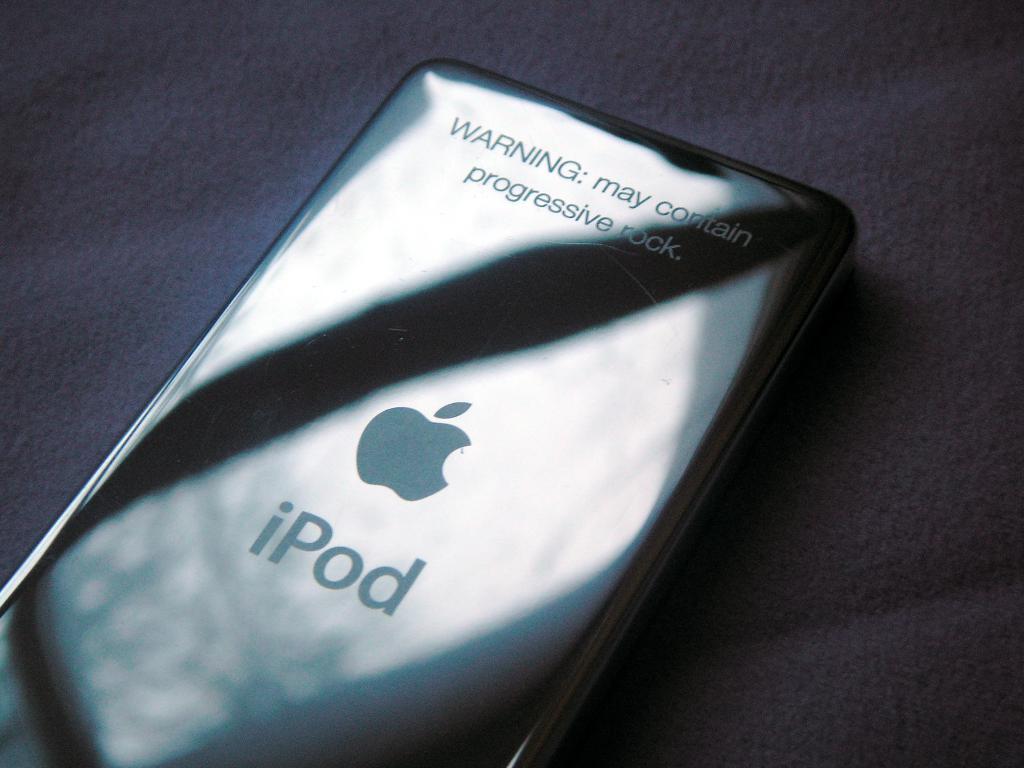How would you summarize this image in a sentence or two? In this image we can see an ipod placed on the surface. 